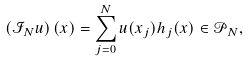Convert formula to latex. <formula><loc_0><loc_0><loc_500><loc_500>\left ( { \mathcal { I } } _ { N } u \right ) ( x ) = \sum _ { j = 0 } ^ { N } u ( x _ { j } ) h _ { j } ( x ) \in { \mathcal { P } } _ { N } ,</formula> 